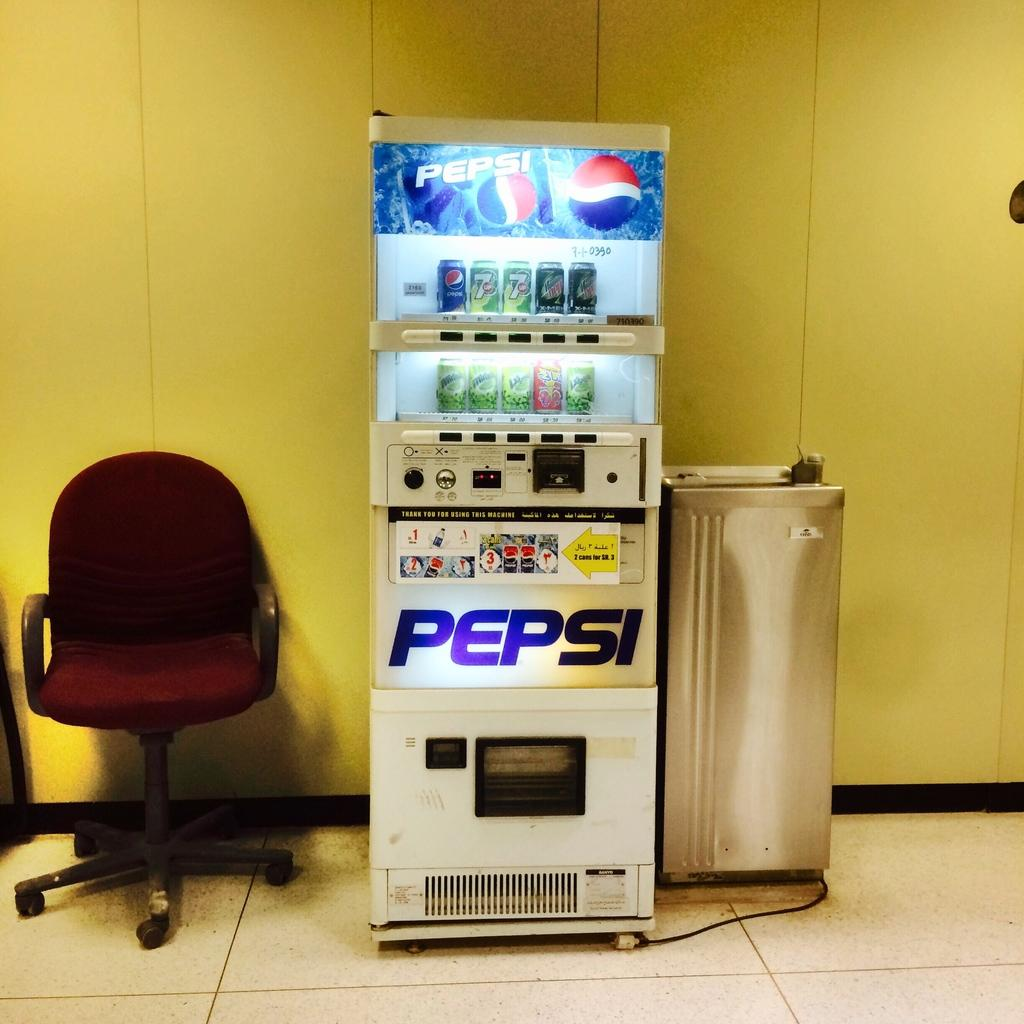<image>
Write a terse but informative summary of the picture. a pepsi vending machine leaning against a yellow wall next toa  red chair 